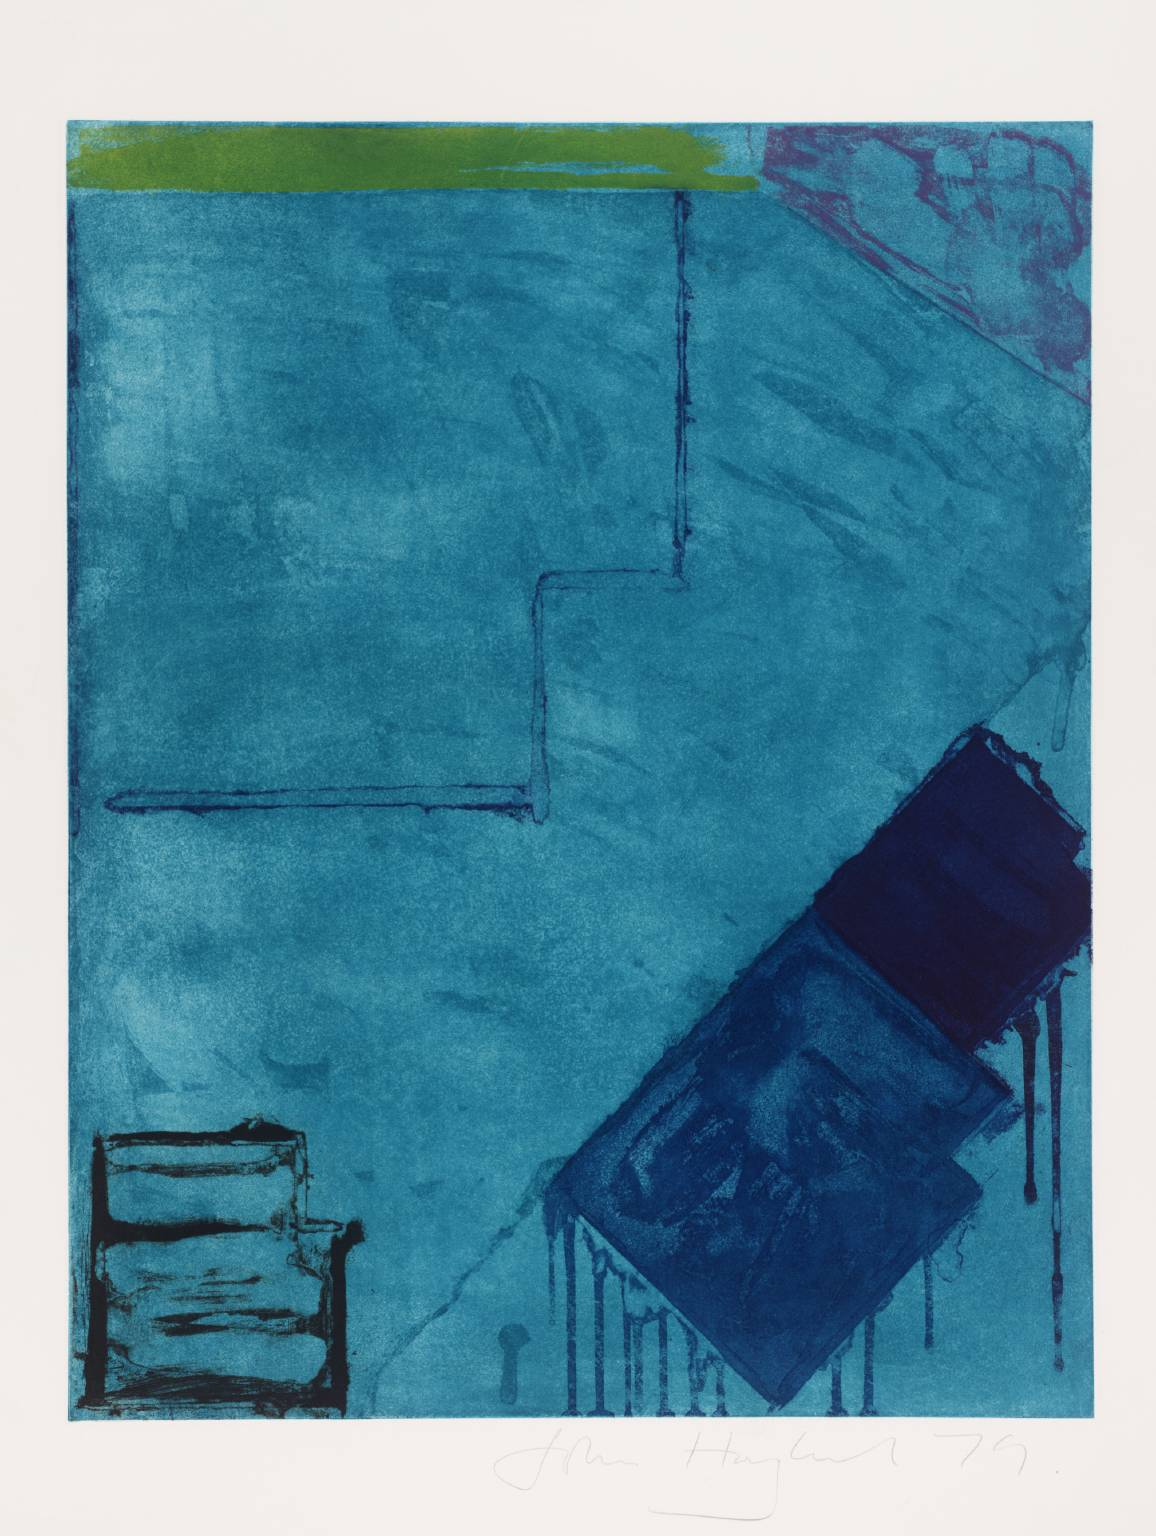What are the key elements in this picture? This image features an abstract composition, with a palette primarily in shades of blue, complemented by a band of green at the top and a streak of pinkish-red on the right side. The use of geometrical shapes, such as the dark blue rectangle and the contrasting lighter blue square, alongside the visible layering technique, suggests that this work might be a print or a mixed media piece. The varying tones and depths of blue create an impression of fluidity, while the solid geometric shapes contrast with this movement, giving a sense of structure to the piece. The brushstrokes or printer's marks add texture and further depth to the image, prompting viewers to ponder the artist's intent and the emotions conveyed by the juxtaposition of color and form. 